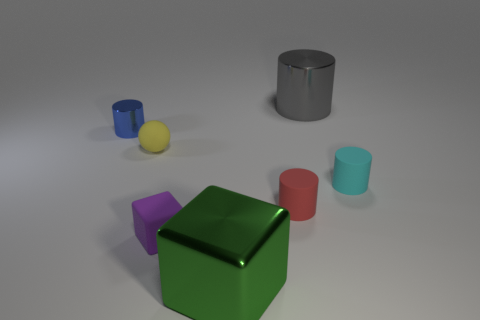The small thing that is to the right of the matte ball and to the left of the metal cube is made of what material?
Offer a terse response. Rubber. Is the number of red things that are to the left of the blue thing less than the number of big cylinders on the left side of the small yellow sphere?
Offer a terse response. No. What is the size of the gray object that is the same material as the large block?
Your answer should be compact. Large. Are there any other things that have the same color as the big metal cube?
Provide a short and direct response. No. Does the small yellow thing have the same material as the cylinder that is left of the yellow matte thing?
Offer a very short reply. No. There is another gray object that is the same shape as the tiny shiny thing; what is its material?
Offer a terse response. Metal. Are there any other things that have the same material as the large green object?
Provide a succinct answer. Yes. Does the large object behind the small red object have the same material as the small cylinder on the left side of the large cube?
Your response must be concise. Yes. There is a thing that is behind the shiny cylinder left of the large object behind the blue object; what color is it?
Make the answer very short. Gray. What number of other objects are there of the same shape as the tiny yellow thing?
Keep it short and to the point. 0. 